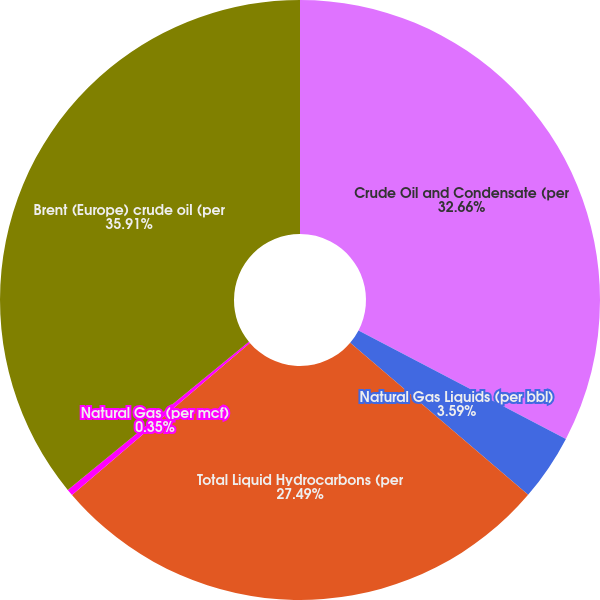Convert chart to OTSL. <chart><loc_0><loc_0><loc_500><loc_500><pie_chart><fcel>Crude Oil and Condensate (per<fcel>Natural Gas Liquids (per bbl)<fcel>Total Liquid Hydrocarbons (per<fcel>Natural Gas (per mcf)<fcel>Brent (Europe) crude oil (per<nl><fcel>32.66%<fcel>3.59%<fcel>27.49%<fcel>0.35%<fcel>35.91%<nl></chart> 